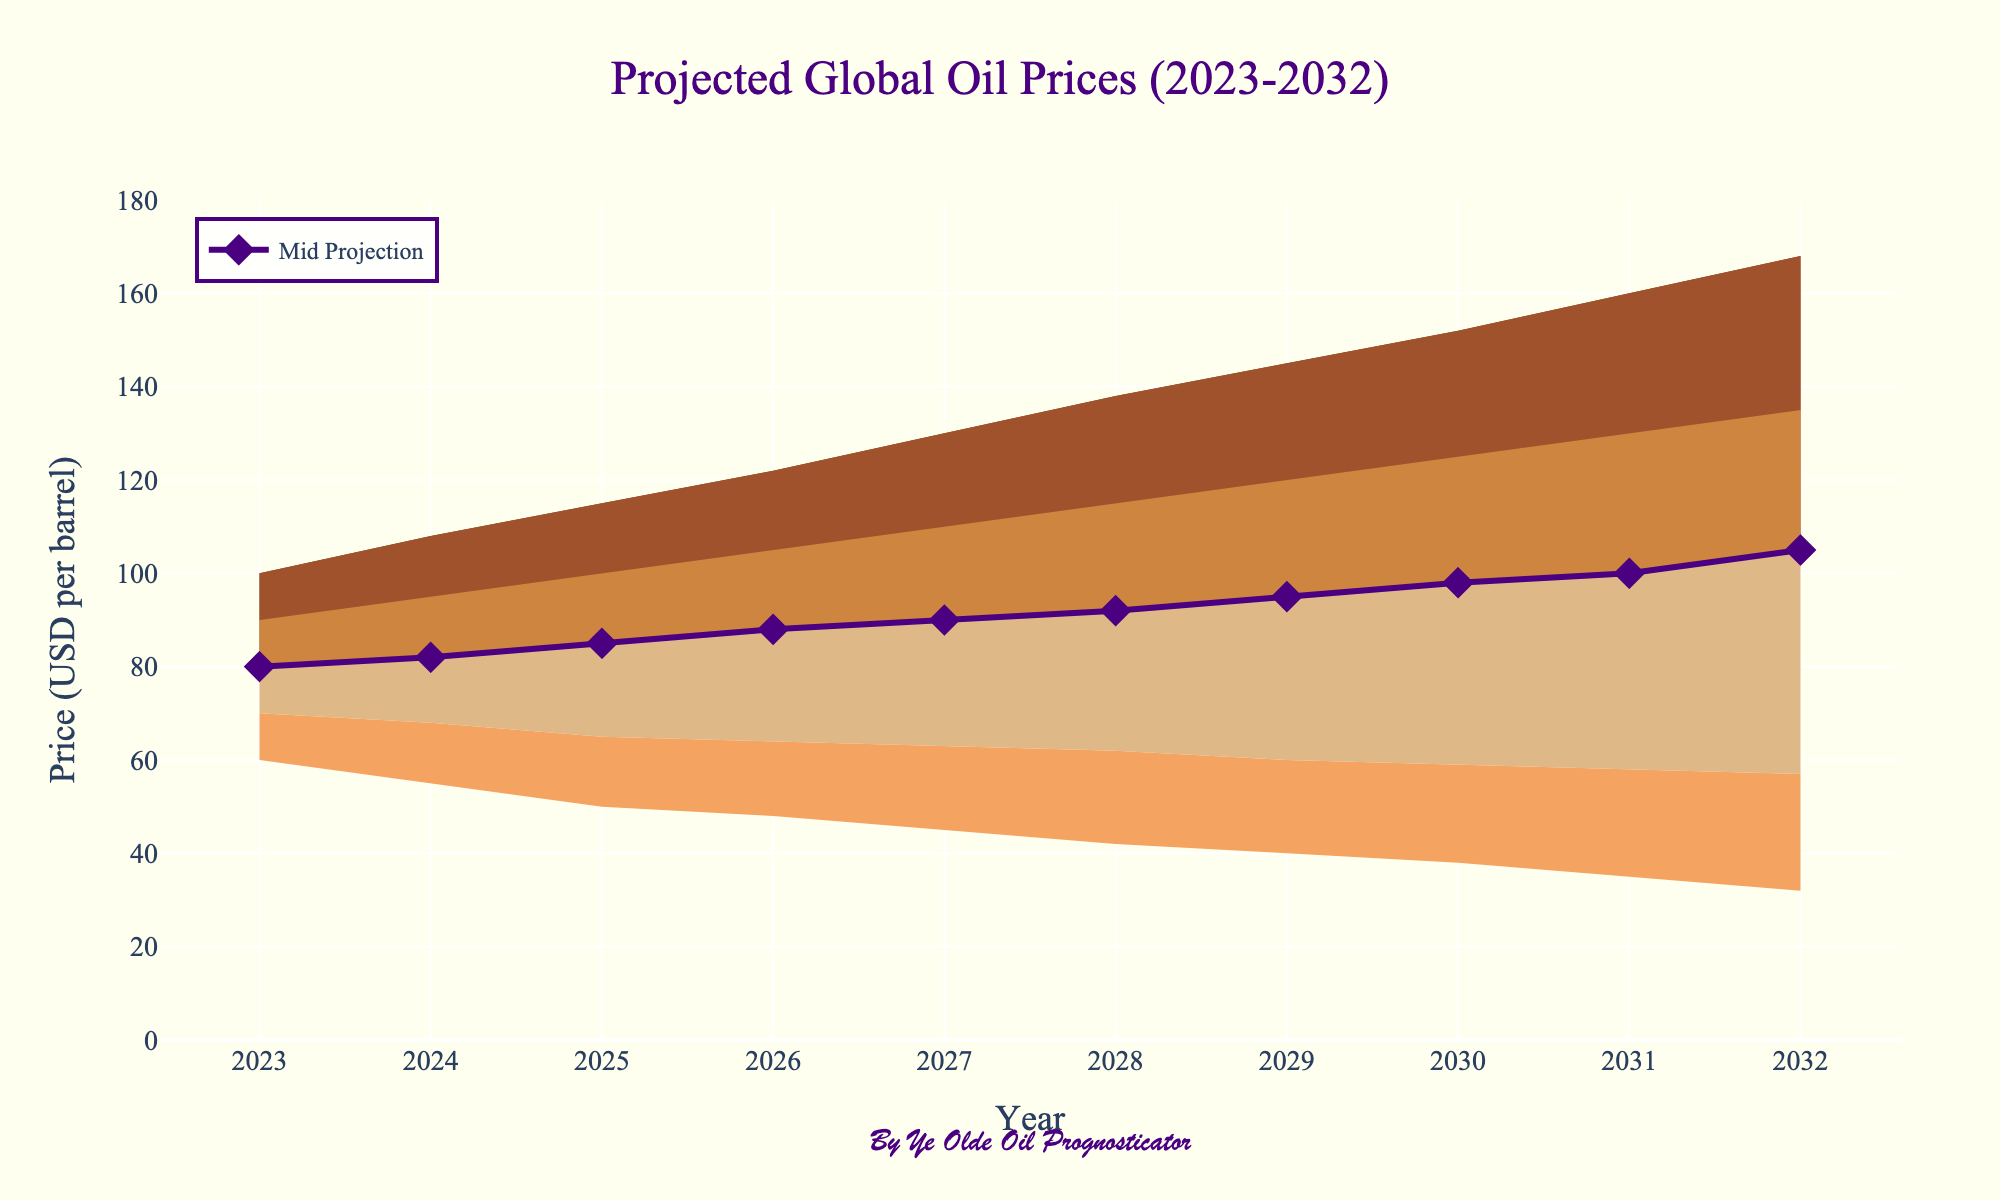What is the title of the figure? The title is prominently displayed at the top of the figure. It reads "Projected Global Oil Prices (2023-2032)."
Answer: Projected Global Oil Prices (2023-2032) How many years are displayed on the x-axis? The years are shown on the x-axis starting from 2023 and ending at 2032. We count each year from 2023 to 2032 inclusively.
Answer: 10 What is the projected mid oil price for the year 2025? The mid oil price for each year is represented by the diamond markers on the central line. For 2025, the corresponding value on the y-axis where the diamond marker is positioned is 85.
Answer: 85 Which year has the lowest "Low" oil price projected, and what is that price? The "Low" oil prices are the lowest values in each year's range. By examining the "Low" series, 2032 has the lowest value at 32.
Answer: 2032, 32 How does the range of oil prices for 2028 compare to that for 2023? Compare the ranges by subtracting the "Low" value from the "High" value for the respective years. For 2023, the range is \(100 - 60 = 40\). For 2028, it is \(138 - 42 = 96\).
Answer: 96 (2028) is larger than 40 (2023) What trend do we see in the mid oil prices from 2023 to 2032? Look at the trajectory of the central line (mid projection). It shows an increasing trend, starting at 80 in 2023 and rising to 105 in 2032.
Answer: Increasing trend What is the oil price range in 2030? The range for any year can be found by noting the "Low" and "High" values. For 2030, the "Low" is 38 and the "High" is 152. Therefore, the range is \(152 - 38 = 114\).
Answer: 114 Which year shows the biggest difference between the "Mid-High" and "High" projections? Calculate the differences for each year. Observing the values, in 2023 the difference is \(100 - 90 = 10\), and similarly for other years. The year 2029 has the largest difference (\(145 - 120 = 25\)).
Answer: 25 in 2029 Do the projected mid oil prices for any years have the same value? By observing the mid values directly or following the diamond markers on the central line, no two years have the same mid projection values.
Answer: No What is the average oil price of the "Mid" projections over the decade? To find this, sum the mid values from 2023 to 2032 and divide by the number of years. \( (80 + 82 + 85 + 88 + 90 + 92 + 95 + 98 + 100 + 105) / 10 = 917 / 10 \).
Answer: 91.7 